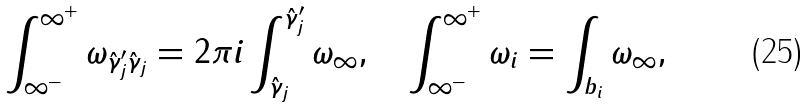Convert formula to latex. <formula><loc_0><loc_0><loc_500><loc_500>\int _ { \infty ^ { - } } ^ { \infty ^ { + } } \omega _ { \hat { \gamma } ^ { \prime } _ { j } \hat { \gamma } _ { j } } = 2 \pi i \int _ { \hat { \gamma } _ { j } } ^ { \hat { \gamma } ^ { \prime } _ { j } } \omega _ { \infty } , \quad \int _ { \infty ^ { - } } ^ { \infty ^ { + } } \omega _ { i } = \int _ { b _ { i } } \omega _ { \infty } ,</formula> 